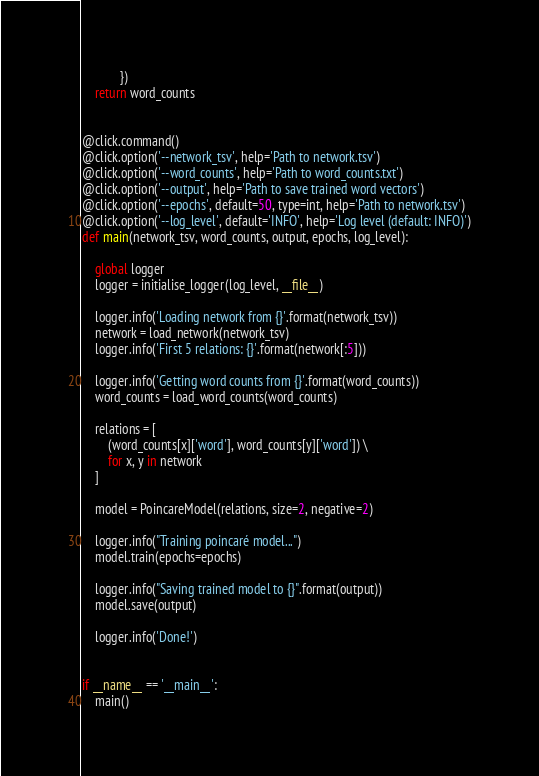Convert code to text. <code><loc_0><loc_0><loc_500><loc_500><_Python_>            })
    return word_counts


@click.command()
@click.option('--network_tsv', help='Path to network.tsv')
@click.option('--word_counts', help='Path to word_counts.txt')
@click.option('--output', help='Path to save trained word vectors')
@click.option('--epochs', default=50, type=int, help='Path to network.tsv')
@click.option('--log_level', default='INFO', help='Log level (default: INFO)')
def main(network_tsv, word_counts, output, epochs, log_level):

    global logger
    logger = initialise_logger(log_level, __file__)

    logger.info('Loading network from {}'.format(network_tsv))
    network = load_network(network_tsv)
    logger.info('First 5 relations: {}'.format(network[:5]))

    logger.info('Getting word counts from {}'.format(word_counts))
    word_counts = load_word_counts(word_counts)

    relations = [
        (word_counts[x]['word'], word_counts[y]['word']) \
        for x, y in network
    ]
    
    model = PoincareModel(relations, size=2, negative=2)

    logger.info("Training poincaré model...")
    model.train(epochs=epochs)

    logger.info("Saving trained model to {}".format(output))
    model.save(output)

    logger.info('Done!')


if __name__ == '__main__':
    main()
</code> 